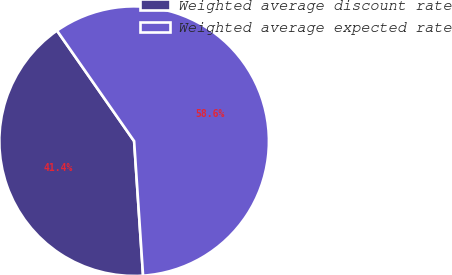Convert chart to OTSL. <chart><loc_0><loc_0><loc_500><loc_500><pie_chart><fcel>Weighted average discount rate<fcel>Weighted average expected rate<nl><fcel>41.36%<fcel>58.64%<nl></chart> 